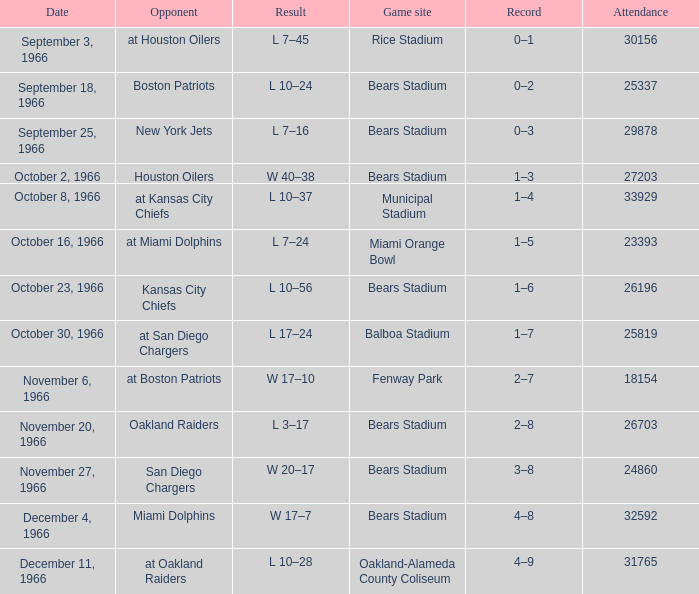Could you parse the entire table as a dict? {'header': ['Date', 'Opponent', 'Result', 'Game site', 'Record', 'Attendance'], 'rows': [['September 3, 1966', 'at Houston Oilers', 'L 7–45', 'Rice Stadium', '0–1', '30156'], ['September 18, 1966', 'Boston Patriots', 'L 10–24', 'Bears Stadium', '0–2', '25337'], ['September 25, 1966', 'New York Jets', 'L 7–16', 'Bears Stadium', '0–3', '29878'], ['October 2, 1966', 'Houston Oilers', 'W 40–38', 'Bears Stadium', '1–3', '27203'], ['October 8, 1966', 'at Kansas City Chiefs', 'L 10–37', 'Municipal Stadium', '1–4', '33929'], ['October 16, 1966', 'at Miami Dolphins', 'L 7–24', 'Miami Orange Bowl', '1–5', '23393'], ['October 23, 1966', 'Kansas City Chiefs', 'L 10–56', 'Bears Stadium', '1–6', '26196'], ['October 30, 1966', 'at San Diego Chargers', 'L 17–24', 'Balboa Stadium', '1–7', '25819'], ['November 6, 1966', 'at Boston Patriots', 'W 17–10', 'Fenway Park', '2–7', '18154'], ['November 20, 1966', 'Oakland Raiders', 'L 3–17', 'Bears Stadium', '2–8', '26703'], ['November 27, 1966', 'San Diego Chargers', 'W 20–17', 'Bears Stadium', '3–8', '24860'], ['December 4, 1966', 'Miami Dolphins', 'W 17–7', 'Bears Stadium', '4–8', '32592'], ['December 11, 1966', 'at Oakland Raiders', 'L 10–28', 'Oakland-Alameda County Coliseum', '4–9', '31765']]} What was the date of the match when the adversary was the miami dolphins? December 4, 1966. 